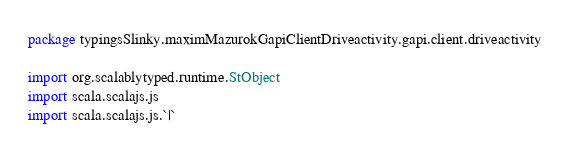Convert code to text. <code><loc_0><loc_0><loc_500><loc_500><_Scala_>package typingsSlinky.maximMazurokGapiClientDriveactivity.gapi.client.driveactivity

import org.scalablytyped.runtime.StObject
import scala.scalajs.js
import scala.scalajs.js.`|`</code> 